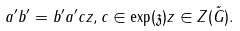<formula> <loc_0><loc_0><loc_500><loc_500>a ^ { \prime } b ^ { \prime } = b ^ { \prime } a ^ { \prime } c z , c \in \exp ( \mathfrak { z } ) z \in Z ( \tilde { G } ) .</formula> 